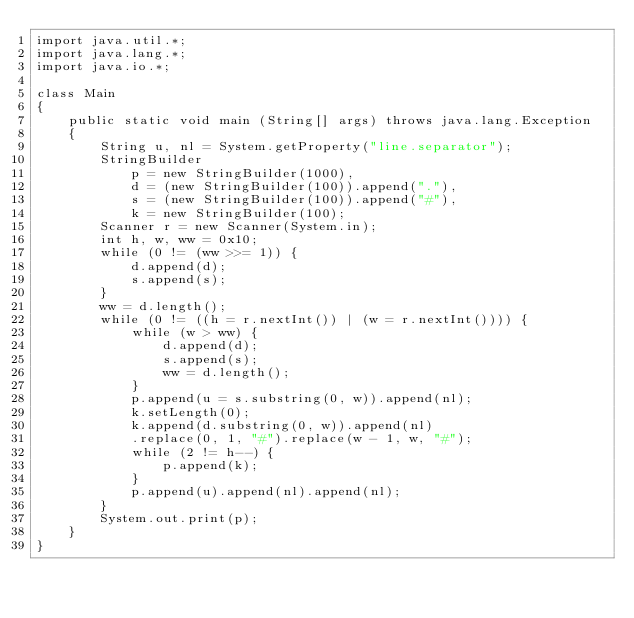Convert code to text. <code><loc_0><loc_0><loc_500><loc_500><_Java_>import java.util.*;
import java.lang.*;
import java.io.*;

class Main
{
	public static void main (String[] args) throws java.lang.Exception
	{
		String u, nl = System.getProperty("line.separator");
		StringBuilder 
			p = new StringBuilder(1000),
		  	d = (new StringBuilder(100)).append("."),
		  	s = (new StringBuilder(100)).append("#"),
		  	k = new StringBuilder(100);
		Scanner r = new Scanner(System.in);
		int h, w, ww = 0x10;
		while (0 != (ww >>= 1)) {
			d.append(d);
			s.append(s);
		}
		ww = d.length();
		while (0 != ((h = r.nextInt()) | (w = r.nextInt()))) {
			while (w > ww) {
				d.append(d);
				s.append(s);
				ww = d.length();
			}
			p.append(u = s.substring(0, w)).append(nl);
			k.setLength(0);
			k.append(d.substring(0, w)).append(nl)
			.replace(0, 1, "#").replace(w - 1, w, "#");
			while (2 != h--) {
				p.append(k);
			}
			p.append(u).append(nl).append(nl);
		}
		System.out.print(p);
	}
}</code> 